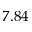<formula> <loc_0><loc_0><loc_500><loc_500>7 . 8 4</formula> 